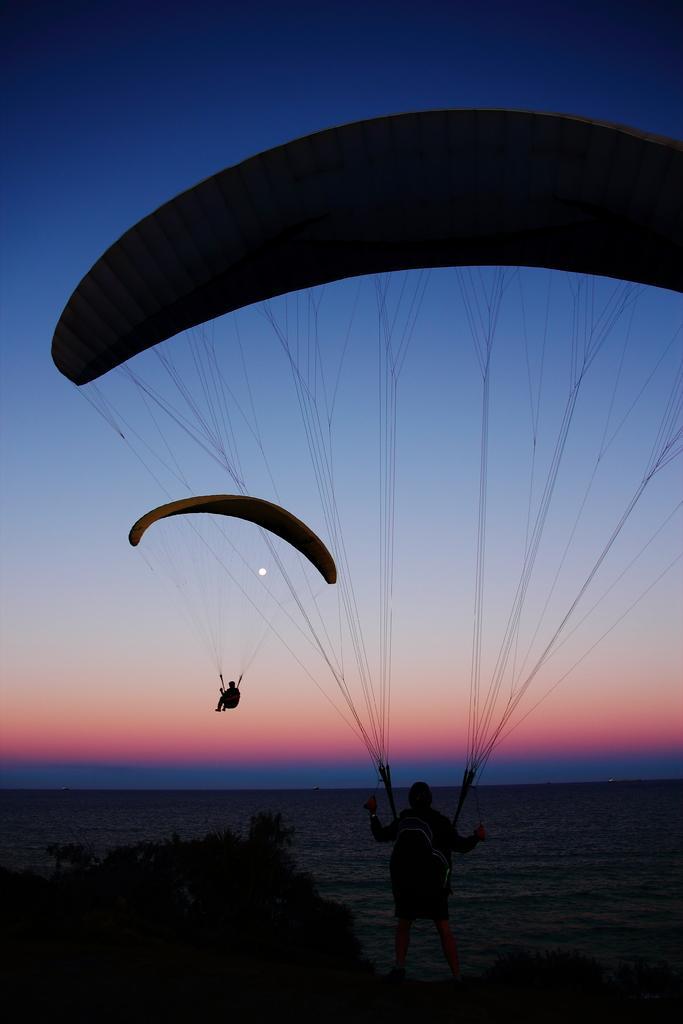How would you summarize this image in a sentence or two? In this picture we can see two people are paragliding, here we can see trees and water and we can see sky, moon in the background. 